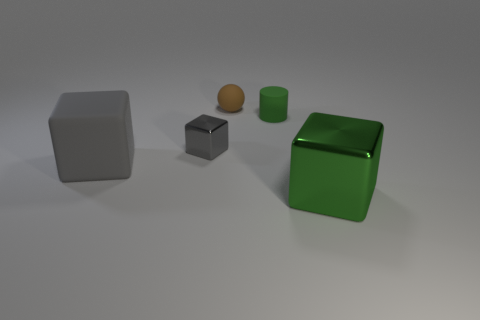Is there any pattern to the arrangement of the objects? The objects are arranged in an uneven, somewhat linear pattern across the image. They are spaced apart with no discernible systematic organization, which could suggest a random positioning or a setup meant to highlight each object distinctly for observation. 